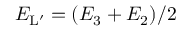Convert formula to latex. <formula><loc_0><loc_0><loc_500><loc_500>{ E } _ { L ^ { \prime } } = ( E _ { 3 } + E _ { 2 } ) / 2</formula> 